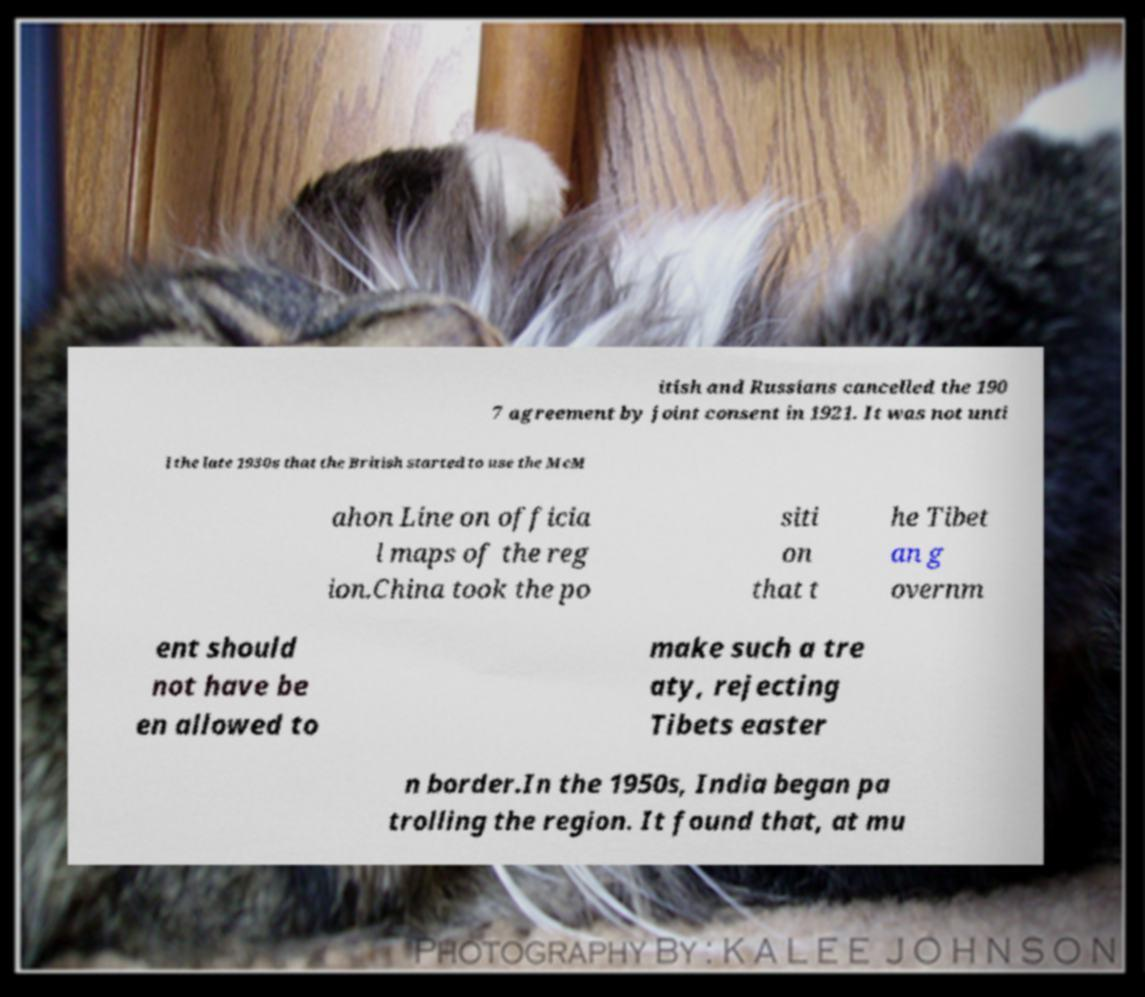Please identify and transcribe the text found in this image. itish and Russians cancelled the 190 7 agreement by joint consent in 1921. It was not unti l the late 1930s that the British started to use the McM ahon Line on officia l maps of the reg ion.China took the po siti on that t he Tibet an g overnm ent should not have be en allowed to make such a tre aty, rejecting Tibets easter n border.In the 1950s, India began pa trolling the region. It found that, at mu 